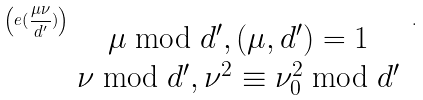<formula> <loc_0><loc_0><loc_500><loc_500>\left ( e ( \frac { \mu \nu } { d ^ { \prime } } ) \right ) _ { \begin{array} { c } \mu \bmod d ^ { \prime } , ( \mu , d ^ { \prime } ) = 1 \\ \nu \bmod d ^ { \prime } , \nu ^ { 2 } \equiv \nu _ { 0 } ^ { 2 } \bmod d ^ { \prime } \end{array} } .</formula> 